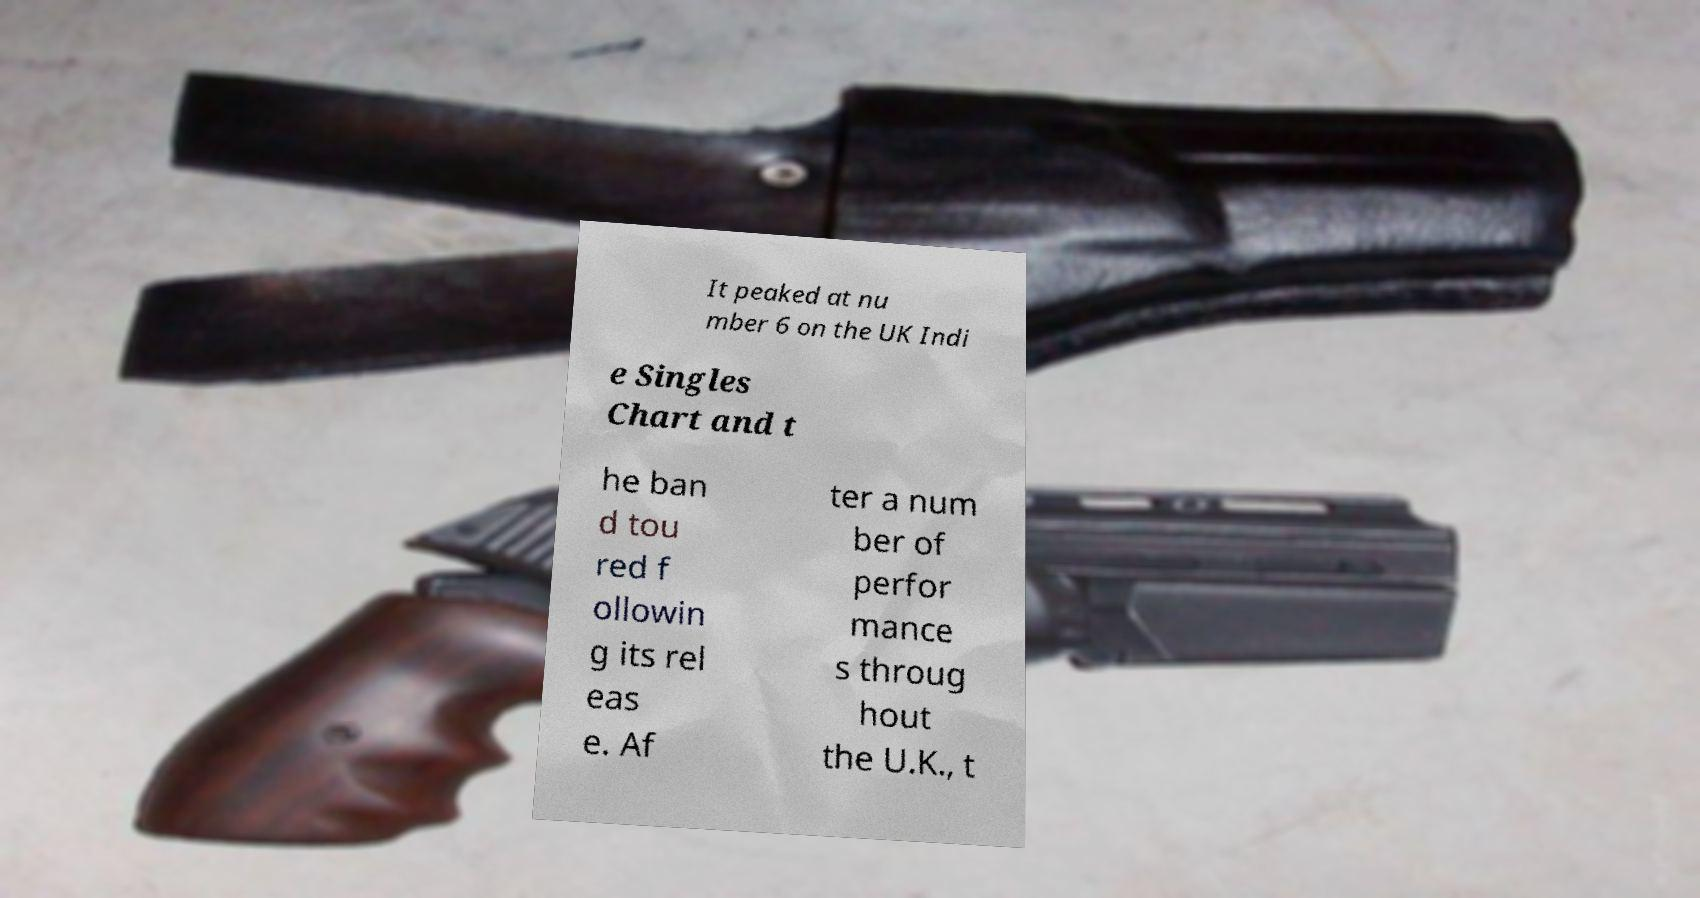What messages or text are displayed in this image? I need them in a readable, typed format. It peaked at nu mber 6 on the UK Indi e Singles Chart and t he ban d tou red f ollowin g its rel eas e. Af ter a num ber of perfor mance s throug hout the U.K., t 